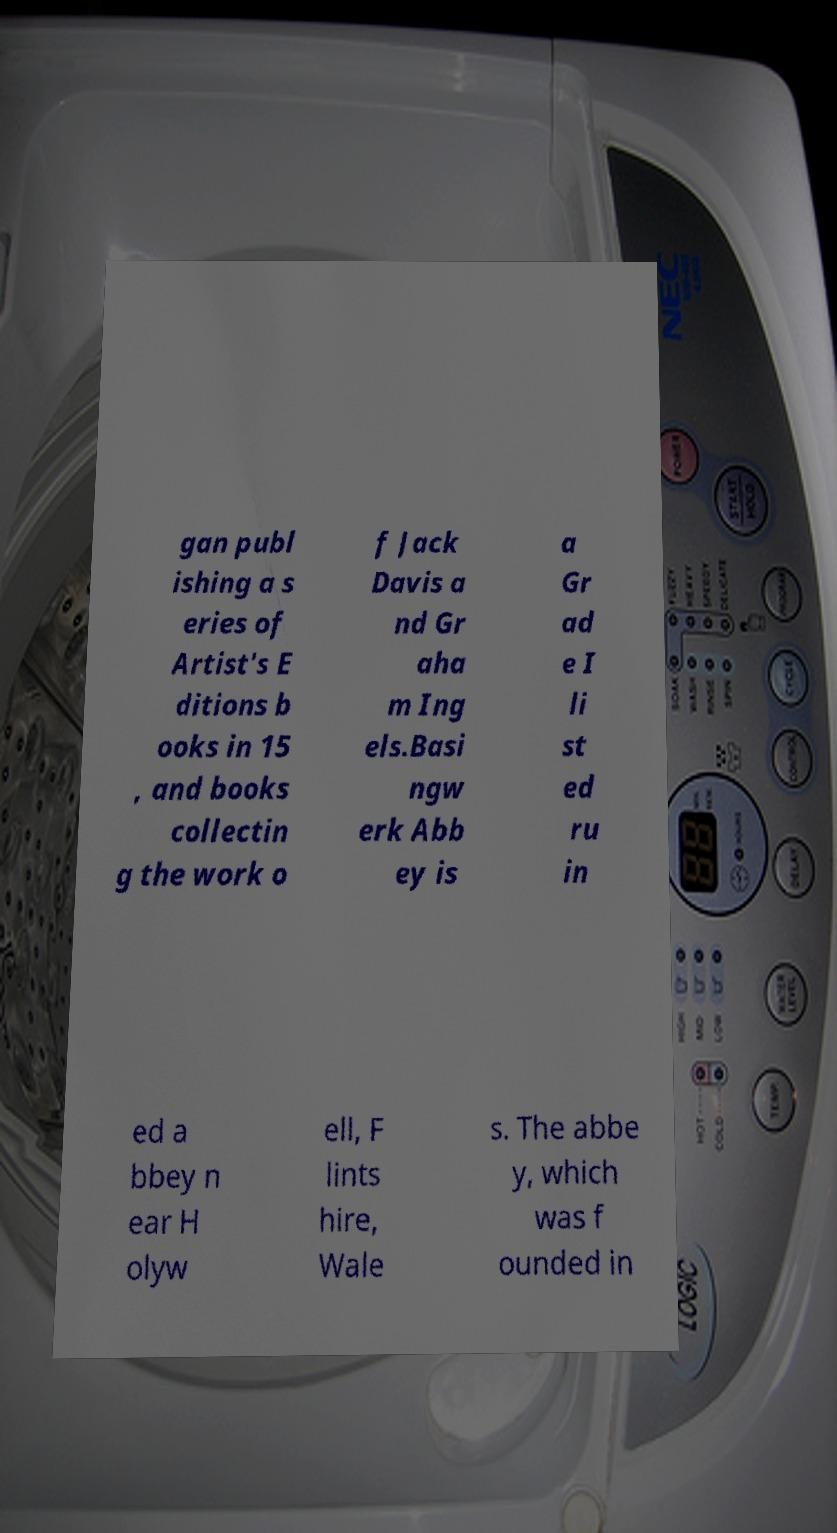I need the written content from this picture converted into text. Can you do that? gan publ ishing a s eries of Artist's E ditions b ooks in 15 , and books collectin g the work o f Jack Davis a nd Gr aha m Ing els.Basi ngw erk Abb ey is a Gr ad e I li st ed ru in ed a bbey n ear H olyw ell, F lints hire, Wale s. The abbe y, which was f ounded in 